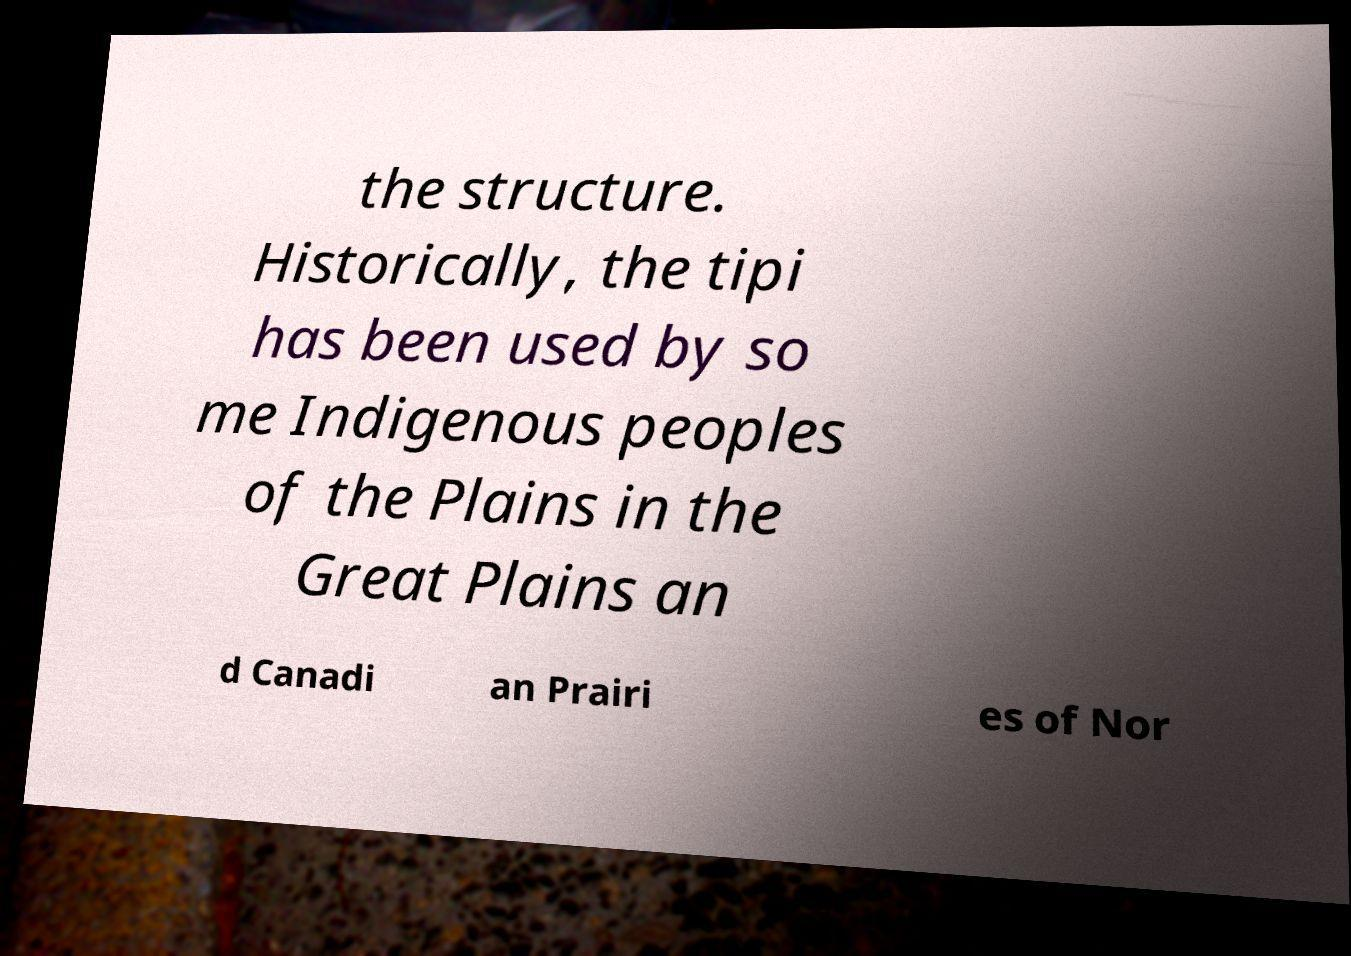Could you assist in decoding the text presented in this image and type it out clearly? the structure. Historically, the tipi has been used by so me Indigenous peoples of the Plains in the Great Plains an d Canadi an Prairi es of Nor 